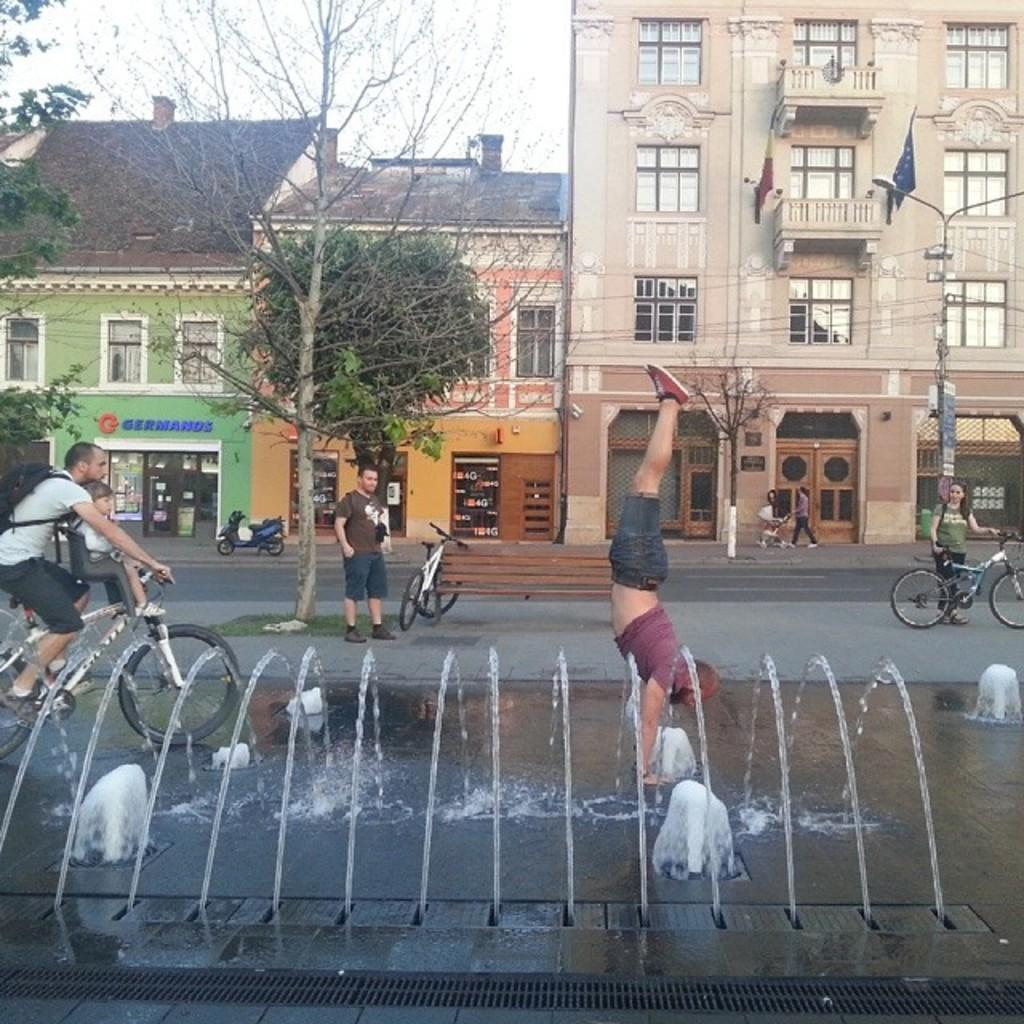Where was the image taken? The image was taken on a road. What can be seen in the background of the image? There are houses in the background. What is the guy doing on the roadside? The guy is performing athletics on the roadside. What type of transportation is visible in the image? There are people riding bicycles in the image. How many visitors can be seen in the image? There is no mention of visitors in the image; it features a guy performing athletics and people riding bicycles. What type of teeth can be seen in the image? There are no teeth visible in the image. 